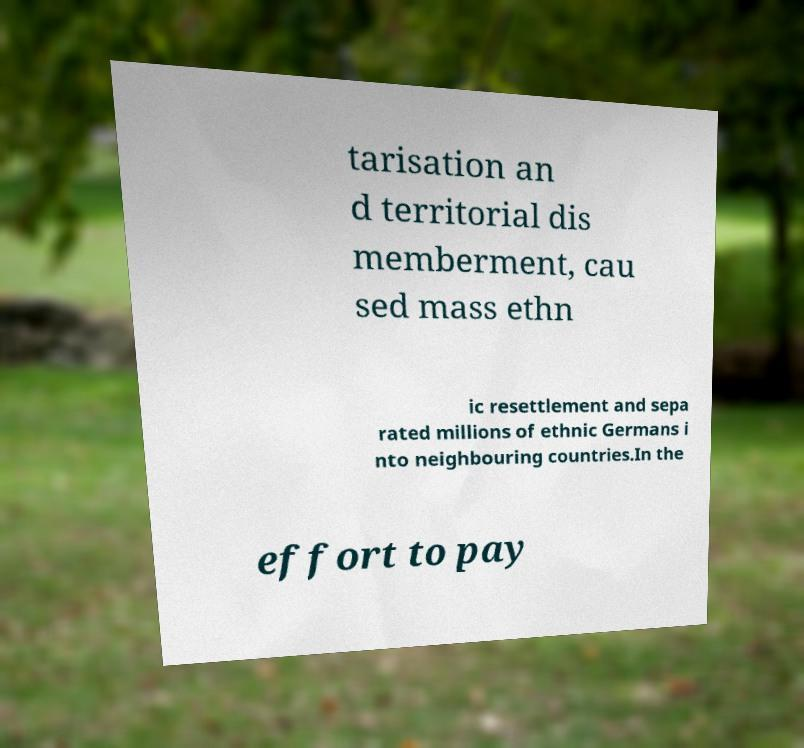Can you accurately transcribe the text from the provided image for me? tarisation an d territorial dis memberment, cau sed mass ethn ic resettlement and sepa rated millions of ethnic Germans i nto neighbouring countries.In the effort to pay 